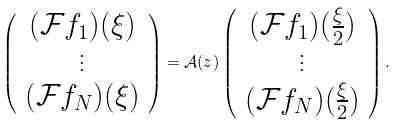Convert formula to latex. <formula><loc_0><loc_0><loc_500><loc_500>\left ( \begin{array} { c } ( \mathcal { F } f _ { 1 } ) ( \xi ) \\ \vdots \\ ( \mathcal { F } f _ { N } ) ( \xi ) \end{array} \right ) = \mathcal { A } ( z ) \left ( \begin{array} { c } ( \mathcal { F } f _ { 1 } ) ( \frac { \xi } { 2 } ) \\ \vdots \\ ( \mathcal { F } f _ { N } ) ( \frac { \xi } { 2 } ) \end{array} \right ) .</formula> 